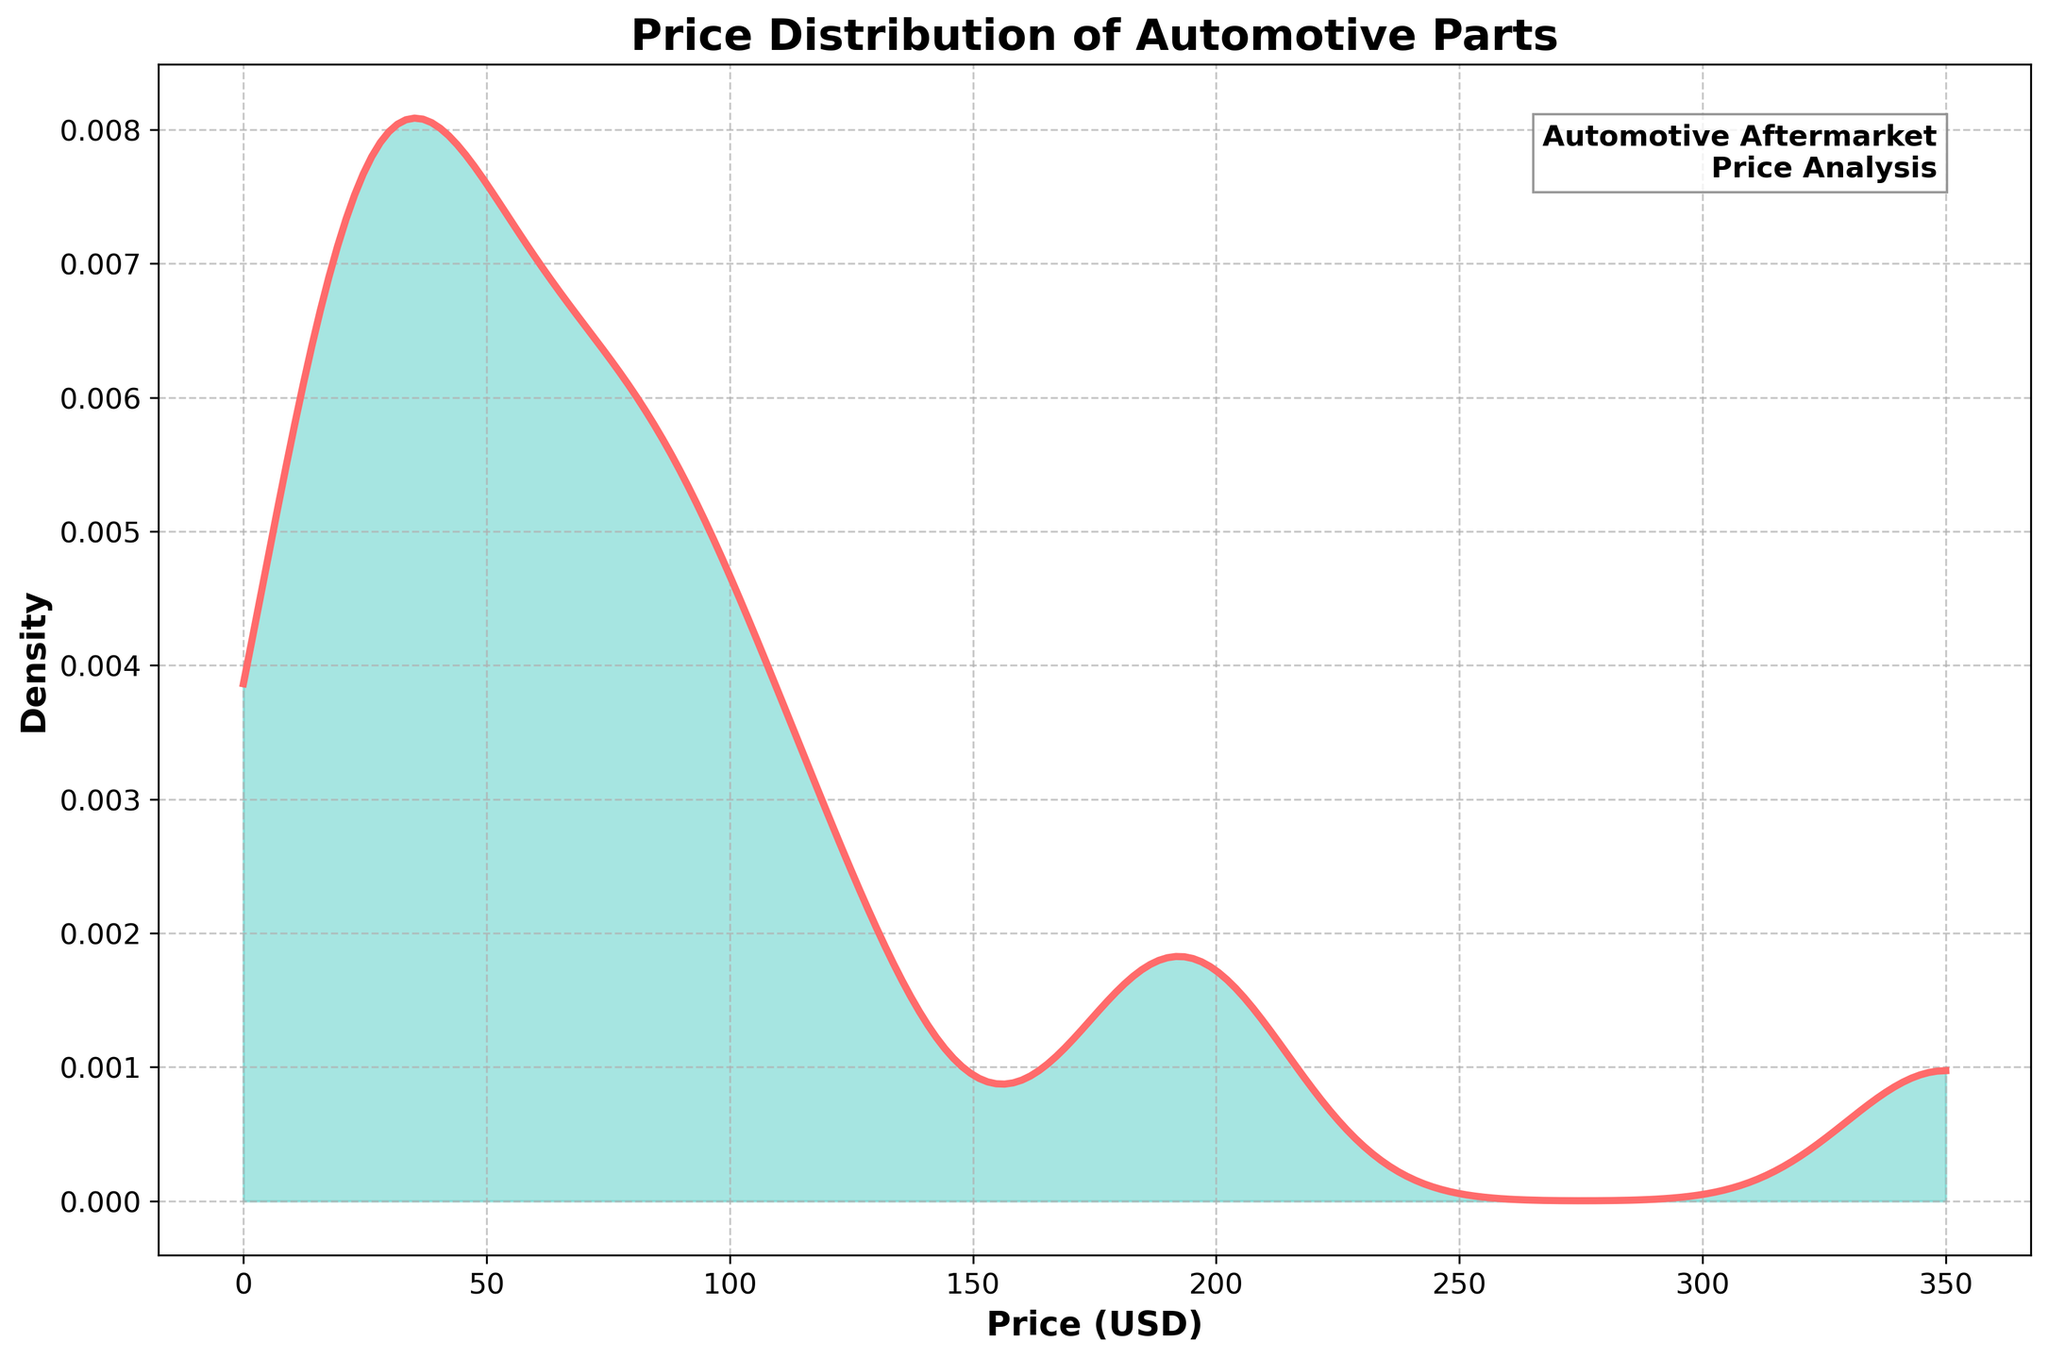What is the title of the density plot? The title is usually displayed at the top center of the plot. By looking at the top of the figure, you can see the phrase "Price Distribution of Automotive Parts."
Answer: Price Distribution of Automotive Parts What are the units of the x-axis? The x-axis represents the price of automotive parts, labeled as "Price (USD)," indicating the unit is in US dollars.
Answer: USD What range of prices is covered on the x-axis? By examining the x-axis, the price range starts from 0 and goes up to a maximum of around 350.
Answer: 0-350 USD What color is used to fill the area under the density curve? By observing the filled area under the density curve, it's visibly shaded with a greenish color.
Answer: Green What does the peak of the density plot represent? The peak indicates the most commonly occurring price range for the automotive parts, where the density is highest.
Answer: Most common price range Which price range has the highest density? By locating the peak of the density curve on the x-axis, the highest density appears to be around the price range of 30-50 USD.
Answer: 30-50 USD What is the overall trend observed in the density plot? The density plot shows a single peak, indicating that most prices are clustered in the lower range, followed by a tail towards higher prices.
Answer: Clustered at lower prices with a tail Compare the densities at 50 USD and 200 USD. Which one is higher? By observing the density curve, the density at 50 USD is visibly higher compared to the density at 200 USD.
Answer: 50 USD What insights can be derived about the price distribution of automotive parts from this density plot? The plot shows that most automotive parts are priced relatively low, with only a few high-priced items, indicative of an accessible market with a few premium-priced outliers.
Answer: Most parts are relatively low-priced, with few high-priced items What does the annotation on the top-right corner represent? The text "Automotive Aftermarket Price Analysis" in the top-right corner provides context about the data being analyzed, specifically focusing on the aftermarket price analysis of automotive parts.
Answer: Context of the analysis 